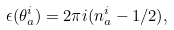Convert formula to latex. <formula><loc_0><loc_0><loc_500><loc_500>\epsilon ( \theta _ { a } ^ { i } ) = 2 \pi i ( n _ { a } ^ { i } - 1 / 2 ) ,</formula> 